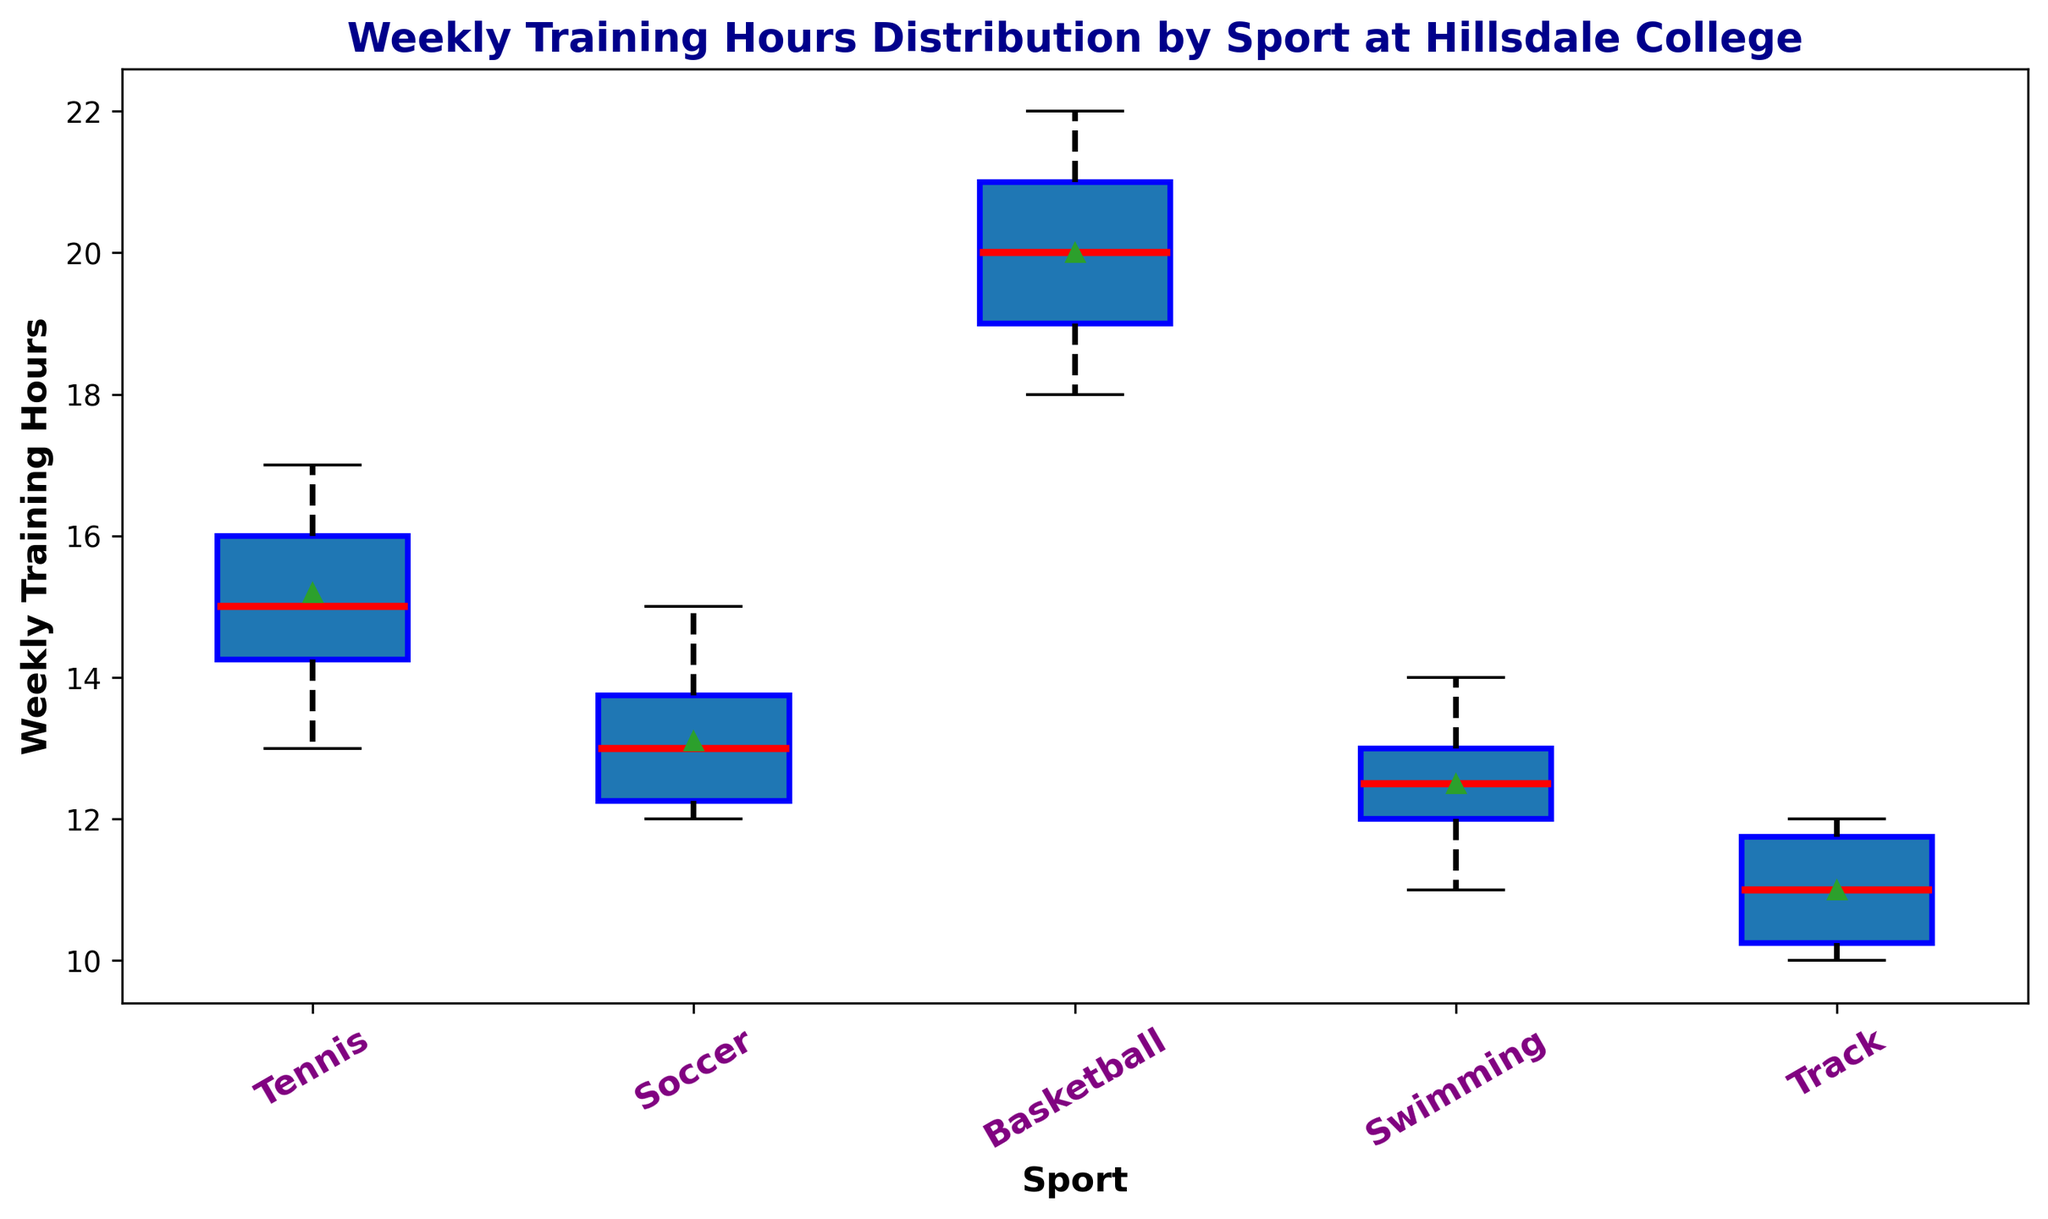What's the median Weekly Training Hours for tennis players? The median value can be obtained by sorting the weekly training hours for tennis players and finding the middle value. The sorted values are 13, 14, 14, 15, 15, 15, 16, 16, 17, 17. The median is the average of the 5th and 6th values, which are both 15.
Answer: 15 Which sport shows the highest median Weekly Training Hours? Look at the central line in each box plot to determine the median values. The sport with the highest median value is basketball.
Answer: Basketball How does the interquartile range (IQR) for tennis compare to soccer? The IQR is the range between the first (Q1) and third quartiles (Q3) of the data. For tennis, Q1 is 14 and Q3 is 16, so IQR = 16 - 14 = 2. For soccer, Q1 is 12, and Q3 is 14, so IQR = 14 - 12 = 2.
Answer: Equal Which sport has the most consistent training hours? Consistency can be considered in terms of the smallest interquartile range (IQR). Look at how compressed the box is; the smallest IQR indicates the most consistent training hours. Track has the smallest IQR.
Answer: Track What is the range of Weekly Training Hours for basketball players? The range is the difference between the maximum and minimum values in the data. For basketball, the minimum value is 18 and the maximum value is 22, giving a range of 22 - 18 = 4.
Answer: 4 Does any sport have a median Weekly Training Hours equal to 12? Look at the central line in each box plot for the median values. Swimming has a median Weekly Training Hours of 12.
Answer: Swimming Which sport has the most outliers in Weekly Training Hours? Outliers are indicated by points outside the whiskers of the box plot. Check for the sport with the most such points. Swimming has the most outliers.
Answer: Swimming How does the maximum Weekly Training Hours in track compare to soccer? Compare the top whisker or the maximum point in both box plots. Both track and soccer have a maximum of 12 weekly training hours.
Answer: Equal 